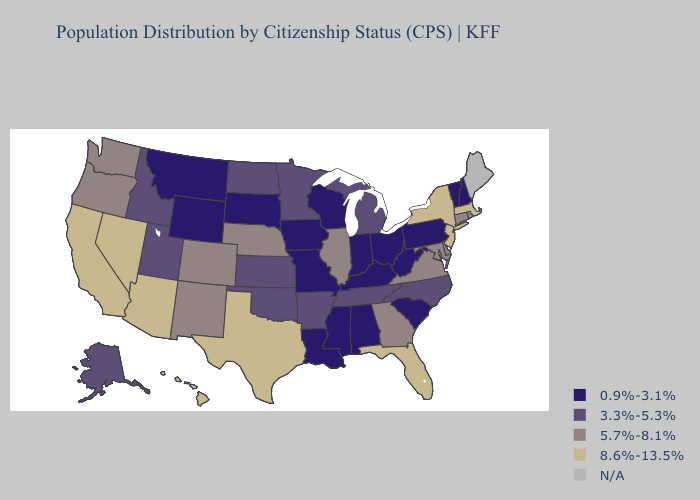What is the value of Hawaii?
Quick response, please. 8.6%-13.5%. Name the states that have a value in the range 3.3%-5.3%?
Keep it brief. Alaska, Arkansas, Idaho, Kansas, Michigan, Minnesota, North Carolina, North Dakota, Oklahoma, Tennessee, Utah. What is the value of Massachusetts?
Give a very brief answer. 8.6%-13.5%. What is the lowest value in the USA?
Quick response, please. 0.9%-3.1%. What is the value of New Mexico?
Write a very short answer. 5.7%-8.1%. Which states have the lowest value in the USA?
Short answer required. Alabama, Indiana, Iowa, Kentucky, Louisiana, Mississippi, Missouri, Montana, New Hampshire, Ohio, Pennsylvania, South Carolina, South Dakota, Vermont, West Virginia, Wisconsin, Wyoming. What is the value of New Mexico?
Short answer required. 5.7%-8.1%. Does the map have missing data?
Short answer required. Yes. Does the map have missing data?
Give a very brief answer. Yes. Name the states that have a value in the range 0.9%-3.1%?
Be succinct. Alabama, Indiana, Iowa, Kentucky, Louisiana, Mississippi, Missouri, Montana, New Hampshire, Ohio, Pennsylvania, South Carolina, South Dakota, Vermont, West Virginia, Wisconsin, Wyoming. Which states have the highest value in the USA?
Short answer required. Arizona, California, Florida, Hawaii, Massachusetts, Nevada, New Jersey, New York, Texas. What is the value of Arizona?
Answer briefly. 8.6%-13.5%. 